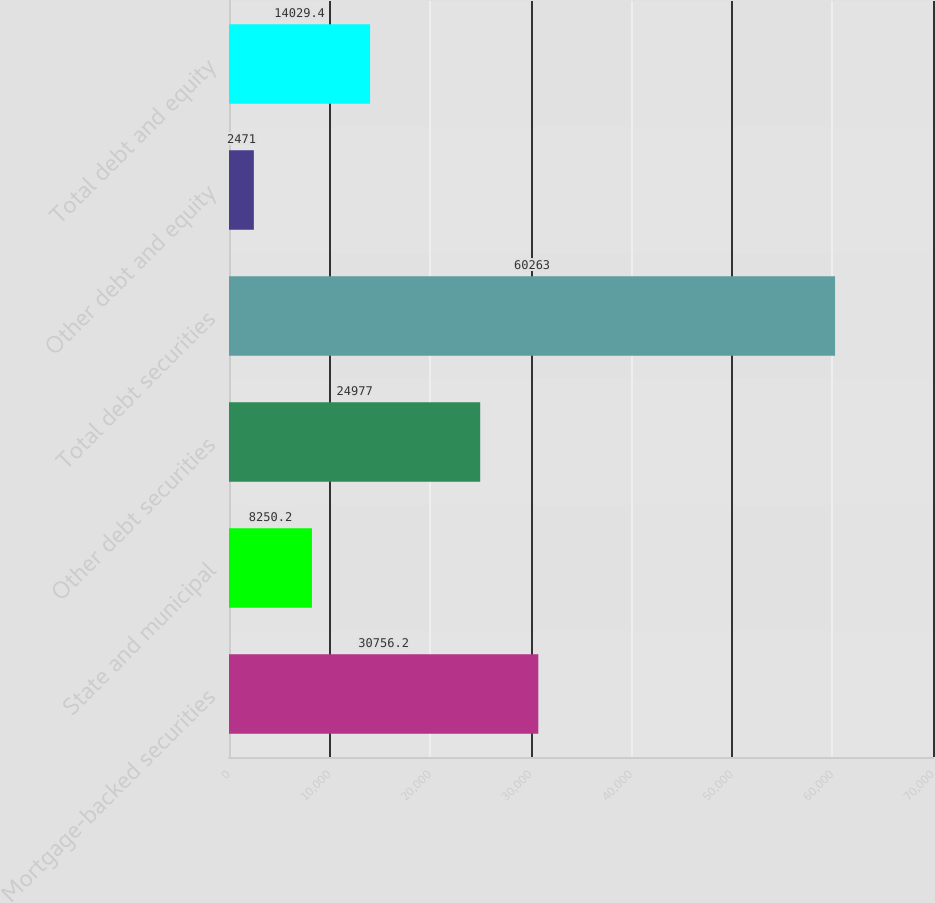Convert chart to OTSL. <chart><loc_0><loc_0><loc_500><loc_500><bar_chart><fcel>Mortgage-backed securities<fcel>State and municipal<fcel>Other debt securities<fcel>Total debt securities<fcel>Other debt and equity<fcel>Total debt and equity<nl><fcel>30756.2<fcel>8250.2<fcel>24977<fcel>60263<fcel>2471<fcel>14029.4<nl></chart> 